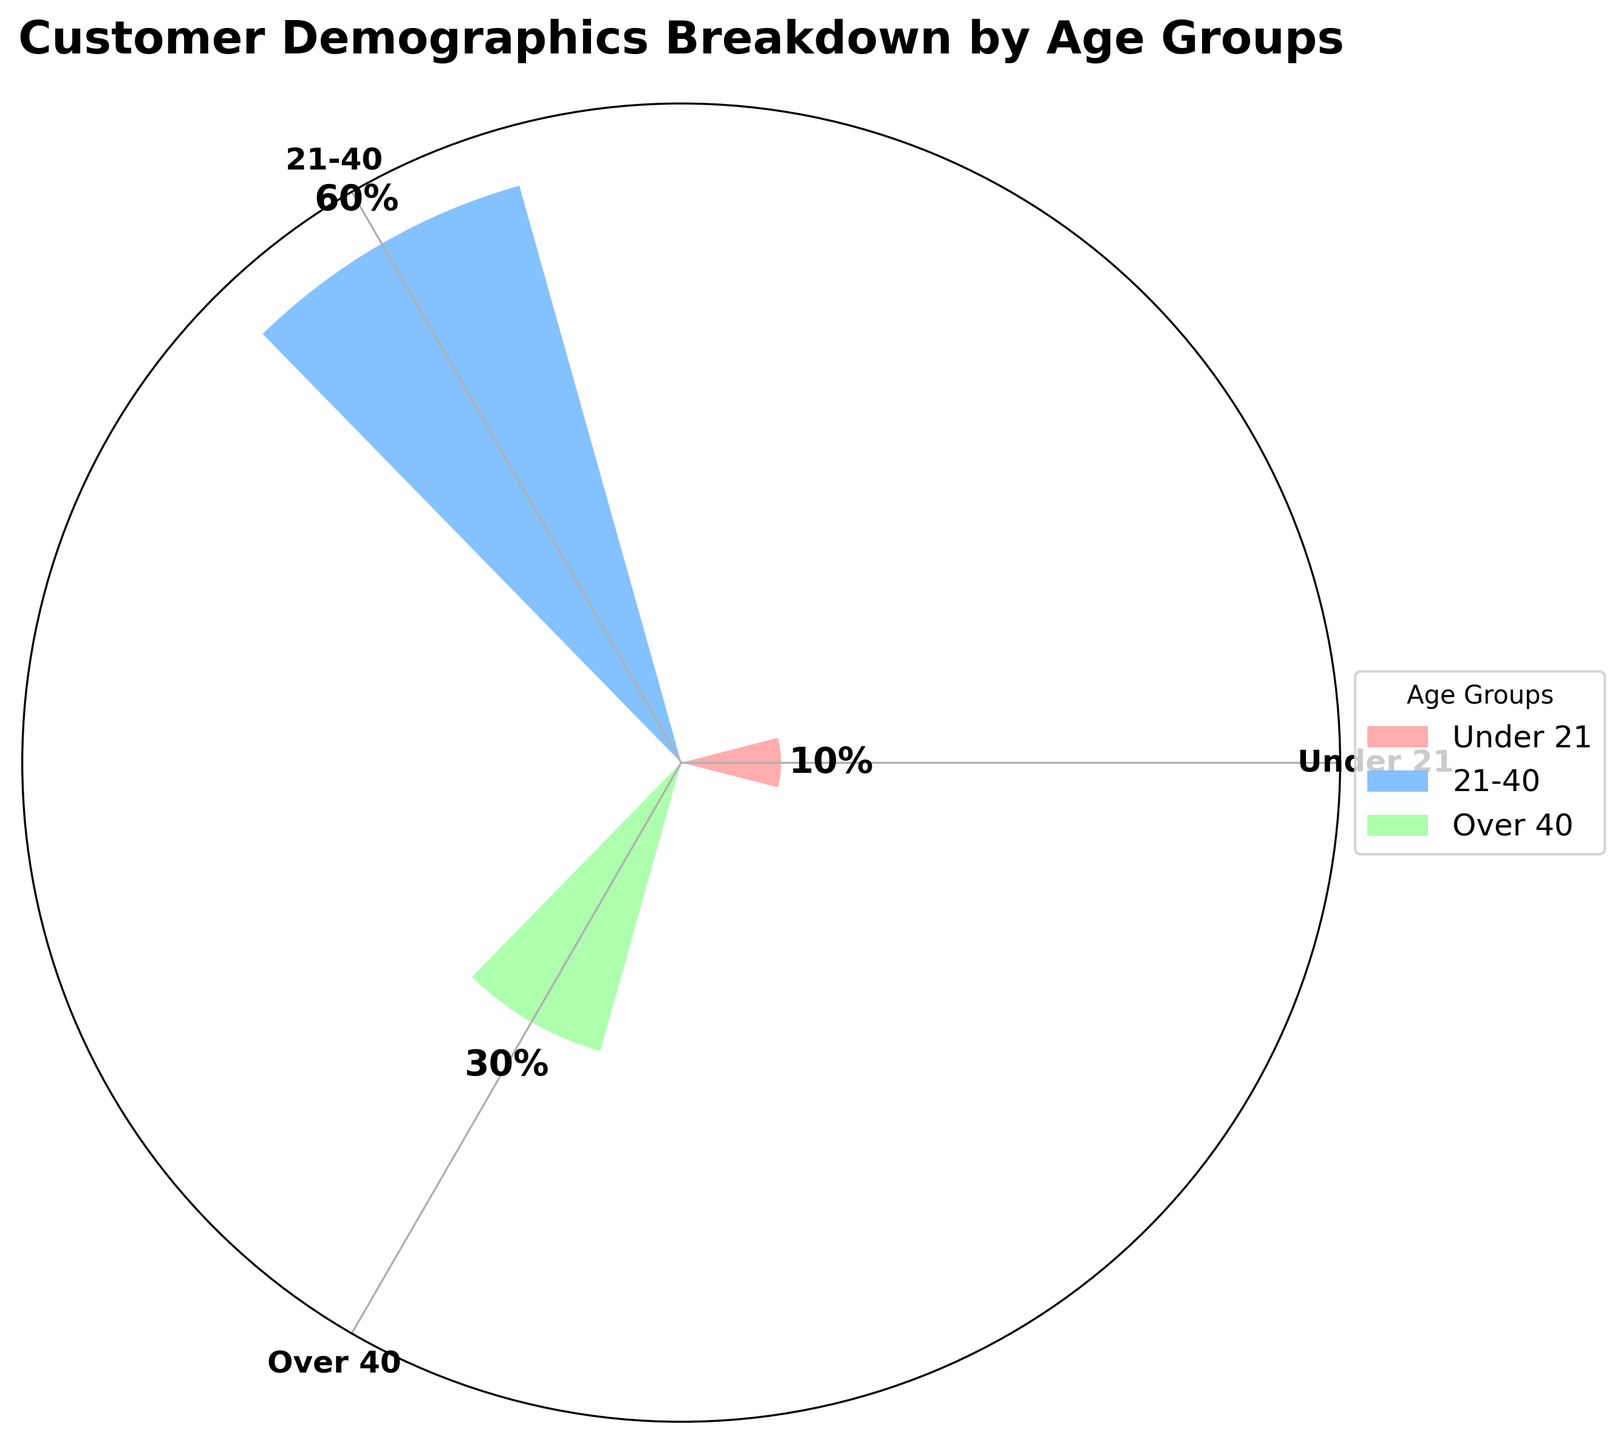What is the title of the chart? The title is typically at the top of the chart, clearly visible, and usually in a larger font size. Here, the title "Customer Demographics Breakdown by Age Groups" is displayed.
Answer: Customer Demographics Breakdown by Age Groups Which age group has the highest percentage? To find the group with the highest percentage, look for the largest bar in the rose chart. The text annotations also help to quickly identify which group has the largest value.
Answer: 21-40 By how much does the percentage of the 21-40 age group exceed that of the Under 21 age group? The percentage of the 21-40 group is 60%, and the Under 21 group is 10%. Subtract 10% from 60% to find the difference.
Answer: 50% What is the combined percentage of customers who are either under 21 or over 40? Sum the percentages of the Under 21 and Over 40 groups. The Under 21 group is 10%, and the Over 40 group is 30%. Adding these together gives 10% + 30% = 40%.
Answer: 40% Which color represents the Over 40 age group in the chart? The color legend usually helps to identify which color corresponds to each age group. The Over 40 group is represented by a shade of green.
Answer: Green How many age groups are represented in the chart? Count the number of different bars or segments in the chart, each corresponding to a different age group.
Answer: Three What is the percentage difference between the Over 40 and Under 21 age groups? The Over 40 group has 30%, and the Under 21 group has 10%. Subtract 10% from 30% to find the difference.
Answer: 20% If you add the percentages of all age groups together, what total do you get? Sum the percentages of all age groups. The data gives 10% (Under 21) + 60% (21-40) + 30% (Over 40). Adding these results in 100%.
Answer: 100% Which age group is represented by the smallest bar in the chart? The smallest bar represents the group with the lowest percentage, which can be quickly identified by looking at the shortest bar in the rose chart.
Answer: Under 21 